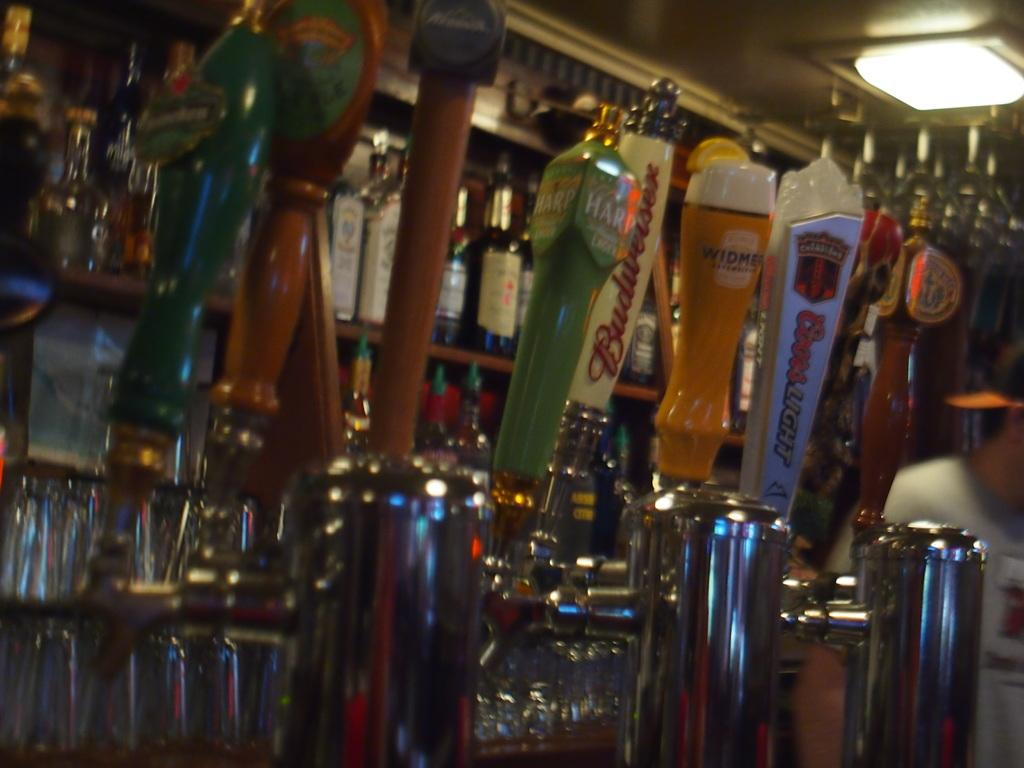<image>
Present a compact description of the photo's key features. Several draft beer handles for Budweiser and Coors among others. 